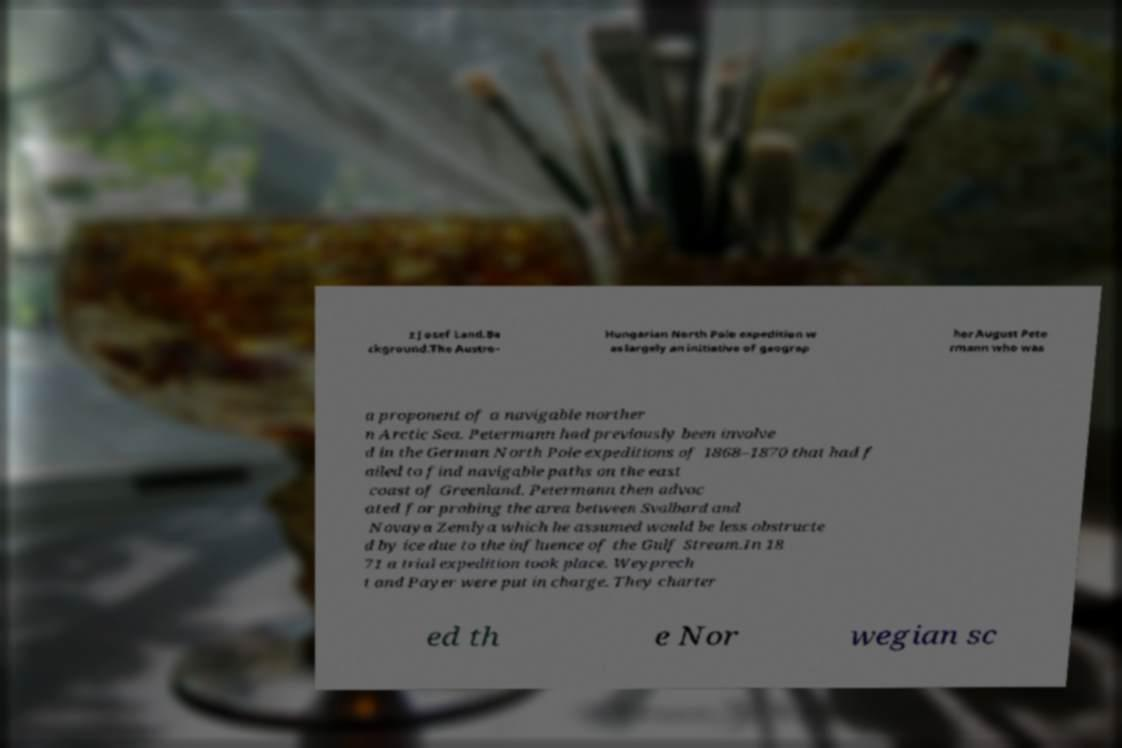What messages or text are displayed in this image? I need them in a readable, typed format. z Josef Land.Ba ckground.The Austro- Hungarian North Pole expedition w as largely an initiative of geograp her August Pete rmann who was a proponent of a navigable norther n Arctic Sea. Petermann had previously been involve d in the German North Pole expeditions of 1868–1870 that had f ailed to find navigable paths on the east coast of Greenland. Petermann then advoc ated for probing the area between Svalbard and Novaya Zemlya which he assumed would be less obstructe d by ice due to the influence of the Gulf Stream.In 18 71 a trial expedition took place. Weyprech t and Payer were put in charge. They charter ed th e Nor wegian sc 